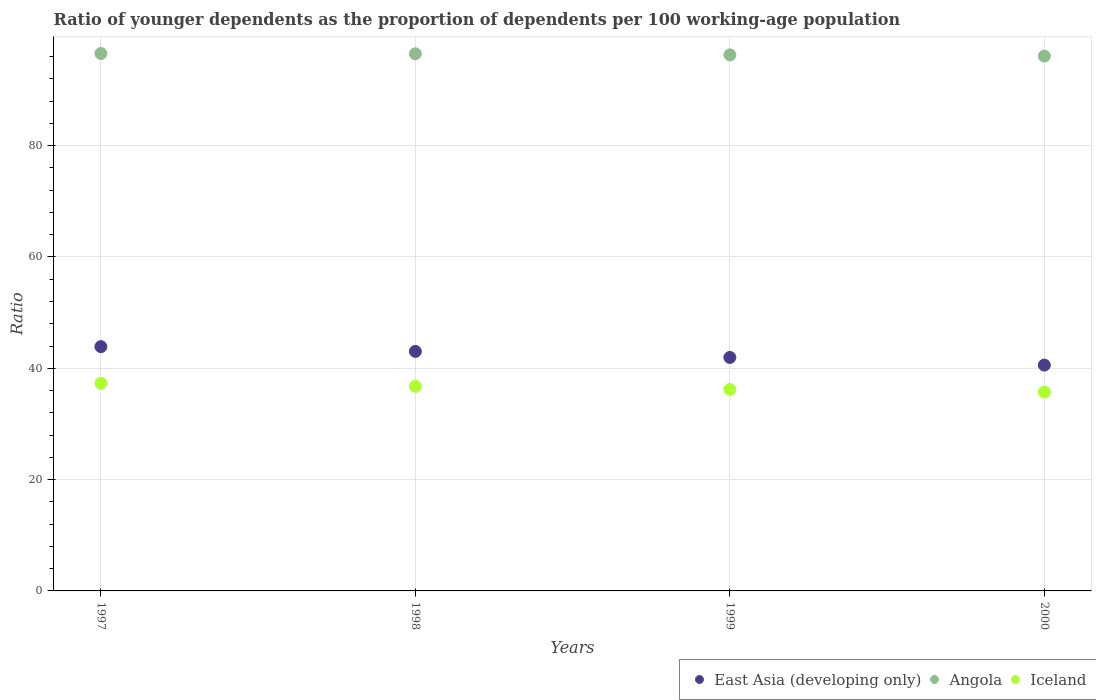What is the age dependency ratio(young) in Iceland in 1999?
Your answer should be very brief. 36.21. Across all years, what is the maximum age dependency ratio(young) in Iceland?
Offer a terse response. 37.32. Across all years, what is the minimum age dependency ratio(young) in East Asia (developing only)?
Keep it short and to the point. 40.57. In which year was the age dependency ratio(young) in Angola maximum?
Offer a very short reply. 1997. In which year was the age dependency ratio(young) in Iceland minimum?
Make the answer very short. 2000. What is the total age dependency ratio(young) in Angola in the graph?
Your response must be concise. 385.46. What is the difference between the age dependency ratio(young) in Angola in 1999 and that in 2000?
Provide a succinct answer. 0.23. What is the difference between the age dependency ratio(young) in Iceland in 1998 and the age dependency ratio(young) in Angola in 1999?
Your answer should be very brief. -59.55. What is the average age dependency ratio(young) in Iceland per year?
Your answer should be compact. 36.51. In the year 1998, what is the difference between the age dependency ratio(young) in East Asia (developing only) and age dependency ratio(young) in Iceland?
Your answer should be compact. 6.27. In how many years, is the age dependency ratio(young) in Iceland greater than 56?
Your answer should be compact. 0. What is the ratio of the age dependency ratio(young) in Iceland in 1997 to that in 1998?
Keep it short and to the point. 1.02. Is the difference between the age dependency ratio(young) in East Asia (developing only) in 1999 and 2000 greater than the difference between the age dependency ratio(young) in Iceland in 1999 and 2000?
Ensure brevity in your answer.  Yes. What is the difference between the highest and the second highest age dependency ratio(young) in Angola?
Your answer should be compact. 0.05. What is the difference between the highest and the lowest age dependency ratio(young) in Iceland?
Ensure brevity in your answer.  1.58. In how many years, is the age dependency ratio(young) in Iceland greater than the average age dependency ratio(young) in Iceland taken over all years?
Your response must be concise. 2. Is it the case that in every year, the sum of the age dependency ratio(young) in Angola and age dependency ratio(young) in Iceland  is greater than the age dependency ratio(young) in East Asia (developing only)?
Keep it short and to the point. Yes. Is the age dependency ratio(young) in Iceland strictly greater than the age dependency ratio(young) in Angola over the years?
Provide a short and direct response. No. How many dotlines are there?
Make the answer very short. 3. Are the values on the major ticks of Y-axis written in scientific E-notation?
Offer a terse response. No. Does the graph contain any zero values?
Keep it short and to the point. No. Does the graph contain grids?
Your answer should be very brief. Yes. What is the title of the graph?
Offer a terse response. Ratio of younger dependents as the proportion of dependents per 100 working-age population. Does "Nepal" appear as one of the legend labels in the graph?
Provide a short and direct response. No. What is the label or title of the X-axis?
Offer a very short reply. Years. What is the label or title of the Y-axis?
Offer a very short reply. Ratio. What is the Ratio of East Asia (developing only) in 1997?
Provide a short and direct response. 43.89. What is the Ratio in Angola in 1997?
Provide a short and direct response. 96.56. What is the Ratio of Iceland in 1997?
Offer a very short reply. 37.32. What is the Ratio of East Asia (developing only) in 1998?
Ensure brevity in your answer.  43.04. What is the Ratio of Angola in 1998?
Your response must be concise. 96.5. What is the Ratio in Iceland in 1998?
Keep it short and to the point. 36.76. What is the Ratio in East Asia (developing only) in 1999?
Keep it short and to the point. 41.95. What is the Ratio of Angola in 1999?
Provide a succinct answer. 96.31. What is the Ratio of Iceland in 1999?
Make the answer very short. 36.21. What is the Ratio in East Asia (developing only) in 2000?
Ensure brevity in your answer.  40.57. What is the Ratio in Angola in 2000?
Your answer should be compact. 96.09. What is the Ratio of Iceland in 2000?
Offer a very short reply. 35.73. Across all years, what is the maximum Ratio of East Asia (developing only)?
Ensure brevity in your answer.  43.89. Across all years, what is the maximum Ratio in Angola?
Make the answer very short. 96.56. Across all years, what is the maximum Ratio in Iceland?
Keep it short and to the point. 37.32. Across all years, what is the minimum Ratio in East Asia (developing only)?
Ensure brevity in your answer.  40.57. Across all years, what is the minimum Ratio in Angola?
Ensure brevity in your answer.  96.09. Across all years, what is the minimum Ratio of Iceland?
Your response must be concise. 35.73. What is the total Ratio of East Asia (developing only) in the graph?
Your answer should be compact. 169.45. What is the total Ratio of Angola in the graph?
Make the answer very short. 385.46. What is the total Ratio in Iceland in the graph?
Provide a succinct answer. 146.03. What is the difference between the Ratio of East Asia (developing only) in 1997 and that in 1998?
Give a very brief answer. 0.85. What is the difference between the Ratio of Angola in 1997 and that in 1998?
Keep it short and to the point. 0.05. What is the difference between the Ratio of Iceland in 1997 and that in 1998?
Provide a short and direct response. 0.56. What is the difference between the Ratio in East Asia (developing only) in 1997 and that in 1999?
Provide a succinct answer. 1.94. What is the difference between the Ratio of Angola in 1997 and that in 1999?
Keep it short and to the point. 0.24. What is the difference between the Ratio in Iceland in 1997 and that in 1999?
Your answer should be very brief. 1.1. What is the difference between the Ratio of East Asia (developing only) in 1997 and that in 2000?
Your answer should be very brief. 3.31. What is the difference between the Ratio in Angola in 1997 and that in 2000?
Provide a succinct answer. 0.47. What is the difference between the Ratio of Iceland in 1997 and that in 2000?
Keep it short and to the point. 1.58. What is the difference between the Ratio of East Asia (developing only) in 1998 and that in 1999?
Your answer should be compact. 1.09. What is the difference between the Ratio of Angola in 1998 and that in 1999?
Your answer should be very brief. 0.19. What is the difference between the Ratio in Iceland in 1998 and that in 1999?
Offer a very short reply. 0.55. What is the difference between the Ratio in East Asia (developing only) in 1998 and that in 2000?
Your answer should be compact. 2.46. What is the difference between the Ratio of Angola in 1998 and that in 2000?
Ensure brevity in your answer.  0.42. What is the difference between the Ratio in Iceland in 1998 and that in 2000?
Your answer should be compact. 1.03. What is the difference between the Ratio of East Asia (developing only) in 1999 and that in 2000?
Give a very brief answer. 1.37. What is the difference between the Ratio in Angola in 1999 and that in 2000?
Offer a very short reply. 0.23. What is the difference between the Ratio of Iceland in 1999 and that in 2000?
Give a very brief answer. 0.48. What is the difference between the Ratio of East Asia (developing only) in 1997 and the Ratio of Angola in 1998?
Your response must be concise. -52.62. What is the difference between the Ratio in East Asia (developing only) in 1997 and the Ratio in Iceland in 1998?
Your answer should be very brief. 7.13. What is the difference between the Ratio of Angola in 1997 and the Ratio of Iceland in 1998?
Ensure brevity in your answer.  59.8. What is the difference between the Ratio of East Asia (developing only) in 1997 and the Ratio of Angola in 1999?
Provide a succinct answer. -52.42. What is the difference between the Ratio of East Asia (developing only) in 1997 and the Ratio of Iceland in 1999?
Offer a terse response. 7.68. What is the difference between the Ratio of Angola in 1997 and the Ratio of Iceland in 1999?
Your answer should be compact. 60.34. What is the difference between the Ratio of East Asia (developing only) in 1997 and the Ratio of Angola in 2000?
Provide a succinct answer. -52.2. What is the difference between the Ratio in East Asia (developing only) in 1997 and the Ratio in Iceland in 2000?
Your answer should be compact. 8.16. What is the difference between the Ratio in Angola in 1997 and the Ratio in Iceland in 2000?
Offer a very short reply. 60.82. What is the difference between the Ratio in East Asia (developing only) in 1998 and the Ratio in Angola in 1999?
Provide a succinct answer. -53.28. What is the difference between the Ratio of East Asia (developing only) in 1998 and the Ratio of Iceland in 1999?
Ensure brevity in your answer.  6.82. What is the difference between the Ratio of Angola in 1998 and the Ratio of Iceland in 1999?
Your answer should be compact. 60.29. What is the difference between the Ratio in East Asia (developing only) in 1998 and the Ratio in Angola in 2000?
Offer a very short reply. -53.05. What is the difference between the Ratio in East Asia (developing only) in 1998 and the Ratio in Iceland in 2000?
Make the answer very short. 7.3. What is the difference between the Ratio in Angola in 1998 and the Ratio in Iceland in 2000?
Your answer should be very brief. 60.77. What is the difference between the Ratio of East Asia (developing only) in 1999 and the Ratio of Angola in 2000?
Your answer should be very brief. -54.14. What is the difference between the Ratio of East Asia (developing only) in 1999 and the Ratio of Iceland in 2000?
Your response must be concise. 6.22. What is the difference between the Ratio in Angola in 1999 and the Ratio in Iceland in 2000?
Provide a short and direct response. 60.58. What is the average Ratio of East Asia (developing only) per year?
Your answer should be compact. 42.36. What is the average Ratio in Angola per year?
Offer a very short reply. 96.37. What is the average Ratio in Iceland per year?
Give a very brief answer. 36.51. In the year 1997, what is the difference between the Ratio in East Asia (developing only) and Ratio in Angola?
Your answer should be very brief. -52.67. In the year 1997, what is the difference between the Ratio of East Asia (developing only) and Ratio of Iceland?
Provide a short and direct response. 6.57. In the year 1997, what is the difference between the Ratio of Angola and Ratio of Iceland?
Your answer should be very brief. 59.24. In the year 1998, what is the difference between the Ratio in East Asia (developing only) and Ratio in Angola?
Keep it short and to the point. -53.47. In the year 1998, what is the difference between the Ratio in East Asia (developing only) and Ratio in Iceland?
Offer a very short reply. 6.27. In the year 1998, what is the difference between the Ratio in Angola and Ratio in Iceland?
Your answer should be compact. 59.74. In the year 1999, what is the difference between the Ratio in East Asia (developing only) and Ratio in Angola?
Give a very brief answer. -54.37. In the year 1999, what is the difference between the Ratio in East Asia (developing only) and Ratio in Iceland?
Provide a succinct answer. 5.73. In the year 1999, what is the difference between the Ratio in Angola and Ratio in Iceland?
Offer a very short reply. 60.1. In the year 2000, what is the difference between the Ratio in East Asia (developing only) and Ratio in Angola?
Provide a succinct answer. -55.51. In the year 2000, what is the difference between the Ratio of East Asia (developing only) and Ratio of Iceland?
Your response must be concise. 4.84. In the year 2000, what is the difference between the Ratio of Angola and Ratio of Iceland?
Provide a short and direct response. 60.35. What is the ratio of the Ratio of East Asia (developing only) in 1997 to that in 1998?
Provide a short and direct response. 1.02. What is the ratio of the Ratio of Iceland in 1997 to that in 1998?
Offer a very short reply. 1.02. What is the ratio of the Ratio in East Asia (developing only) in 1997 to that in 1999?
Offer a terse response. 1.05. What is the ratio of the Ratio in Angola in 1997 to that in 1999?
Offer a terse response. 1. What is the ratio of the Ratio of Iceland in 1997 to that in 1999?
Offer a very short reply. 1.03. What is the ratio of the Ratio in East Asia (developing only) in 1997 to that in 2000?
Make the answer very short. 1.08. What is the ratio of the Ratio in Angola in 1997 to that in 2000?
Ensure brevity in your answer.  1. What is the ratio of the Ratio in Iceland in 1997 to that in 2000?
Offer a very short reply. 1.04. What is the ratio of the Ratio of East Asia (developing only) in 1998 to that in 1999?
Make the answer very short. 1.03. What is the ratio of the Ratio in Angola in 1998 to that in 1999?
Your answer should be very brief. 1. What is the ratio of the Ratio in Iceland in 1998 to that in 1999?
Your answer should be very brief. 1.02. What is the ratio of the Ratio in East Asia (developing only) in 1998 to that in 2000?
Provide a short and direct response. 1.06. What is the ratio of the Ratio in Angola in 1998 to that in 2000?
Offer a very short reply. 1. What is the ratio of the Ratio of Iceland in 1998 to that in 2000?
Your answer should be compact. 1.03. What is the ratio of the Ratio in East Asia (developing only) in 1999 to that in 2000?
Provide a short and direct response. 1.03. What is the ratio of the Ratio of Iceland in 1999 to that in 2000?
Offer a very short reply. 1.01. What is the difference between the highest and the second highest Ratio in East Asia (developing only)?
Your answer should be very brief. 0.85. What is the difference between the highest and the second highest Ratio of Angola?
Offer a terse response. 0.05. What is the difference between the highest and the second highest Ratio of Iceland?
Keep it short and to the point. 0.56. What is the difference between the highest and the lowest Ratio in East Asia (developing only)?
Your response must be concise. 3.31. What is the difference between the highest and the lowest Ratio in Angola?
Offer a terse response. 0.47. What is the difference between the highest and the lowest Ratio of Iceland?
Make the answer very short. 1.58. 